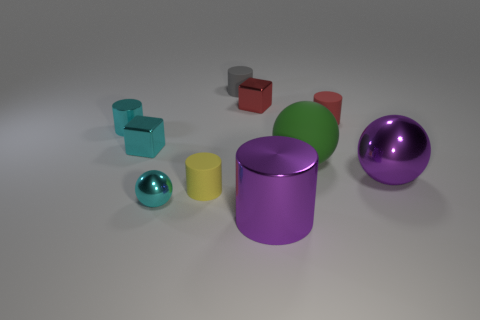Subtract all cyan cylinders. How many cylinders are left? 4 Subtract all cyan cylinders. How many cylinders are left? 4 Subtract all brown cylinders. Subtract all red spheres. How many cylinders are left? 5 Subtract all spheres. How many objects are left? 7 Subtract 0 brown balls. How many objects are left? 10 Subtract all tiny brown metallic cylinders. Subtract all small cyan blocks. How many objects are left? 9 Add 3 cyan shiny objects. How many cyan shiny objects are left? 6 Add 7 small brown matte cylinders. How many small brown matte cylinders exist? 7 